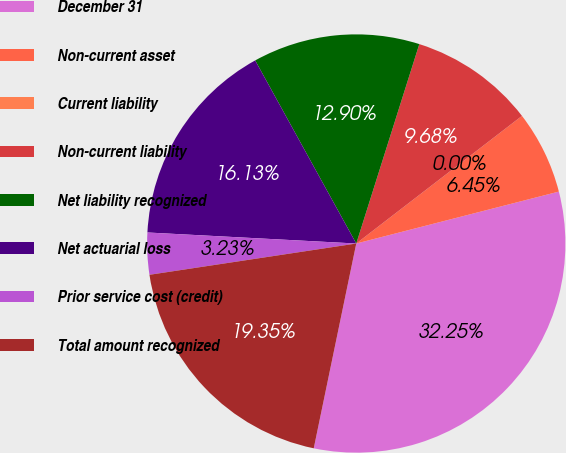<chart> <loc_0><loc_0><loc_500><loc_500><pie_chart><fcel>December 31<fcel>Non-current asset<fcel>Current liability<fcel>Non-current liability<fcel>Net liability recognized<fcel>Net actuarial loss<fcel>Prior service cost (credit)<fcel>Total amount recognized<nl><fcel>32.25%<fcel>6.45%<fcel>0.0%<fcel>9.68%<fcel>12.9%<fcel>16.13%<fcel>3.23%<fcel>19.35%<nl></chart> 